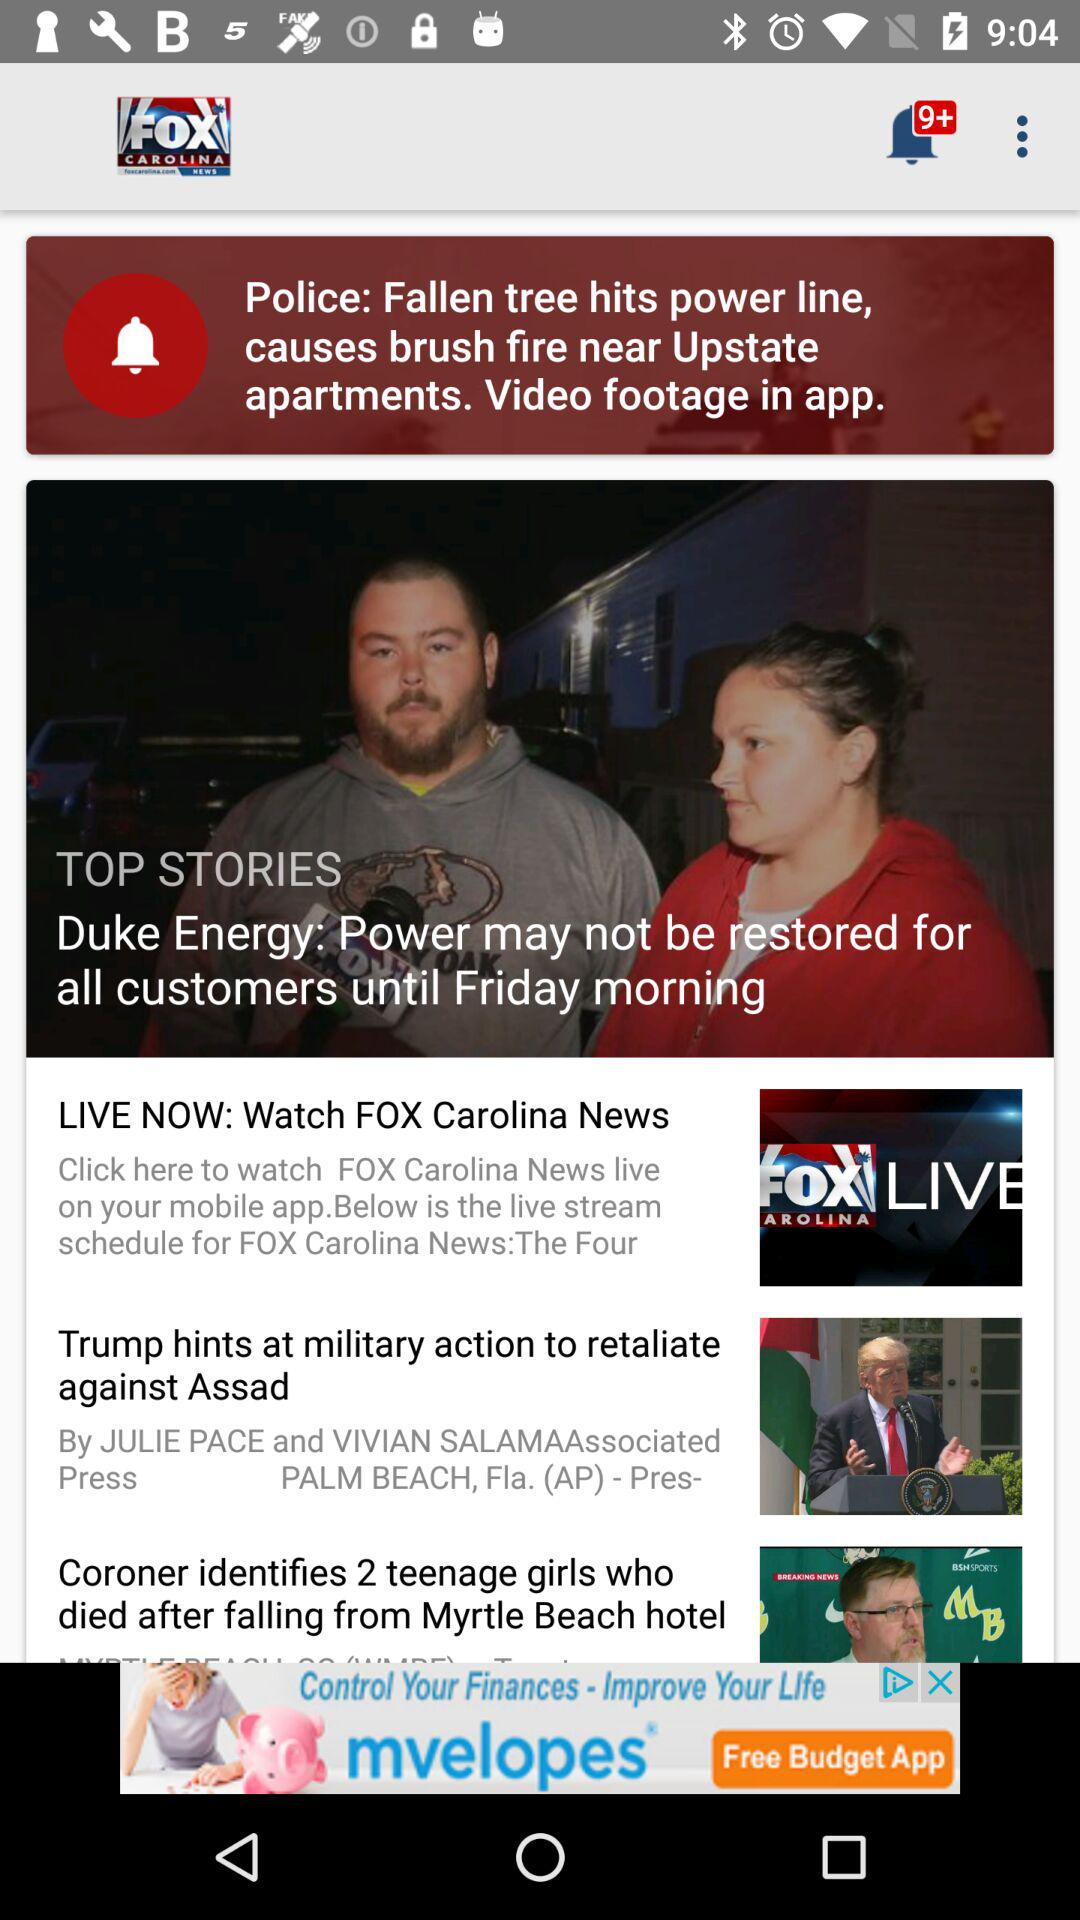What are the top stories? The top stories are "Duke Energy: Power may not be restored for all customers until Friday morning", "LIVE NOW: Watch FOX Carolina News", "Trump hints at military action to retaliate against Assad" and "Coroner identifies 2 teenage girls who died after falling from Myrtle Beach hotel". 